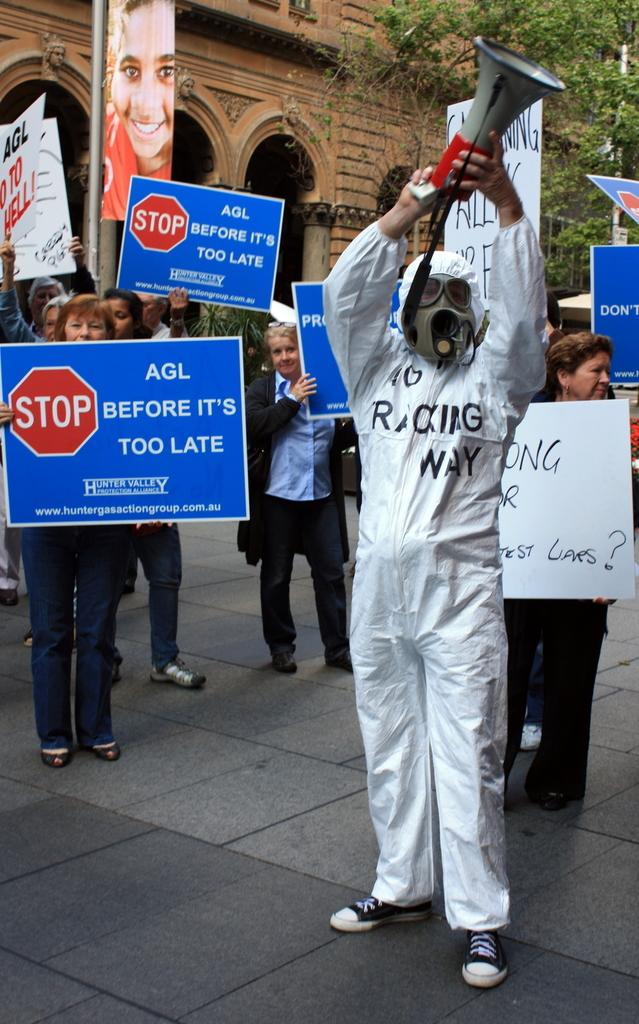What are the people in the image doing? The people in the image are protesting. Can you describe the person on the right side of the image? The person on the right side of the image is wearing a white dress. What type of brick is the person on the right side of the image holding? There is no brick present in the image; the person on the right side is wearing a white dress. What book is the person on the left side of the image reading during the protest? There is no book present in the image, as the people are protesting and not reading. 